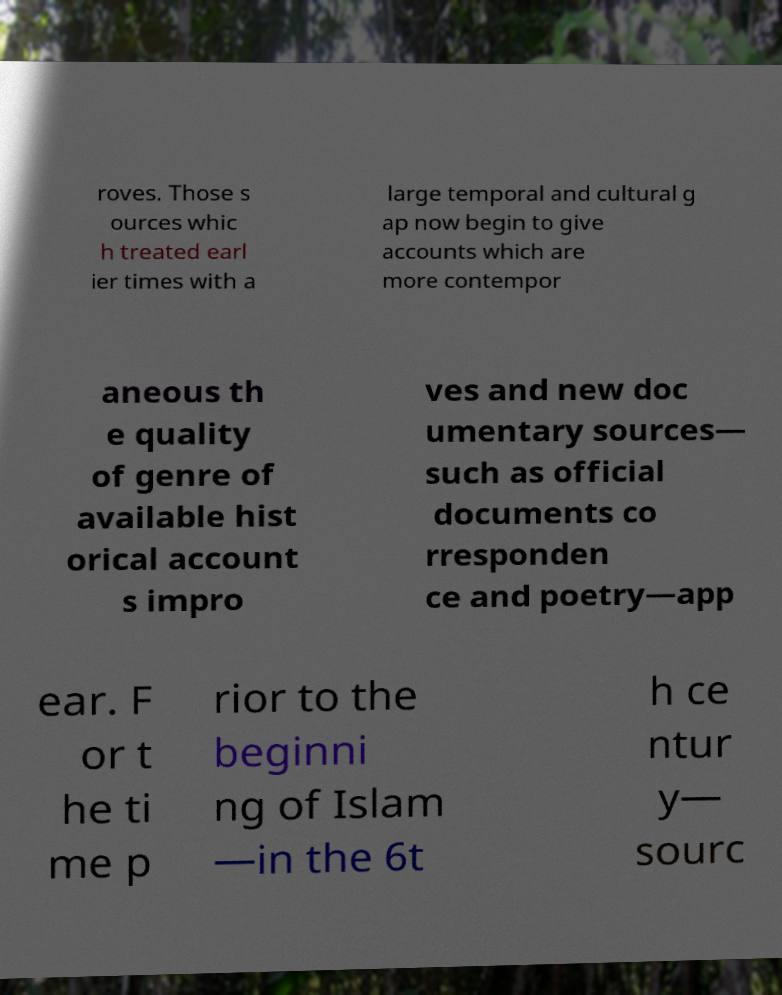Please identify and transcribe the text found in this image. roves. Those s ources whic h treated earl ier times with a large temporal and cultural g ap now begin to give accounts which are more contempor aneous th e quality of genre of available hist orical account s impro ves and new doc umentary sources— such as official documents co rresponden ce and poetry—app ear. F or t he ti me p rior to the beginni ng of Islam —in the 6t h ce ntur y— sourc 